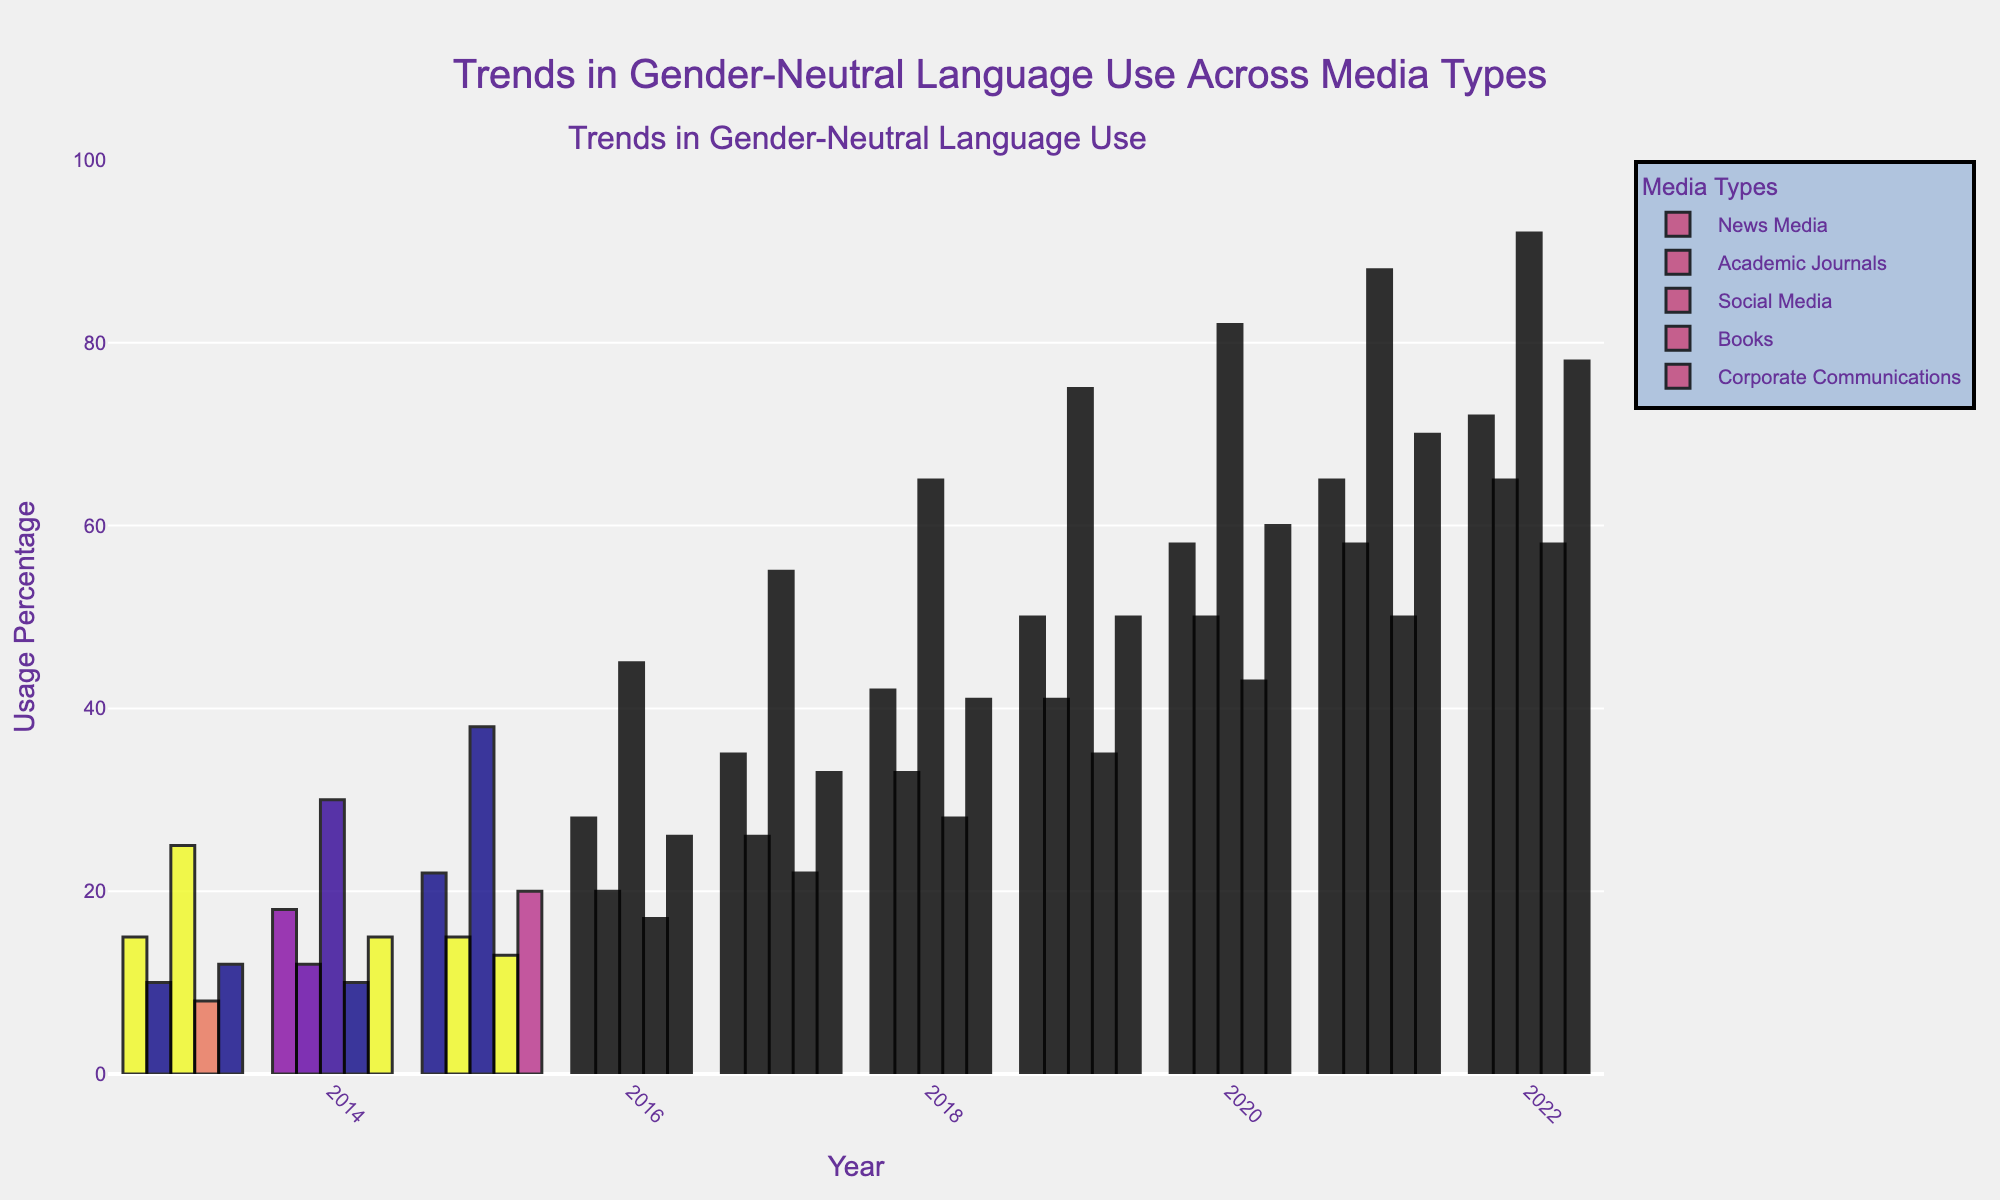What is the trend in the use of gender-neutral language in News Media from 2013 to 2022? First, observe the bars representing News Media from 2013 to 2022. You will notice that the height of the bars increases steadily over the years, indicating a continuous upward trend.
Answer: Continuous upward trend Which media type shows the highest increase in the use of gender-neutral language between 2013 and 2022? Compare the height differences of bars for each media type from 2013 to 2022. Social Media starts at 25 in 2013 and goes up to 92 in 2022, making it the highest increase, which is 67.
Answer: Social Media In 2020, how much higher is the use of gender-neutral language in News Media compared to Books? Identify the bars for News Media and Books in 2020. News Media is at 58, and Books are at 43. Subtract 43 from 58 to find the difference.
Answer: 15 Which media category consistently shows the lowest usage of gender-neutral language over the years? Compare the bars for all categories from 2013 to 2022 and identify the smallest values. Books consistently have the lowest values across all years.
Answer: Books What is the average usage of gender-neutral language in Corporate Communications from 2013 to 2022? Sum the values for Corporate Communications (12 + 15 + 20 + 26 + 33 + 41 + 50 + 60 + 70 + 78) which equals 405. Divide this by the number of years (10) to find the average.
Answer: 40.5 Between which consecutive years did Academic Journals see the highest increase in the use of gender-neutral language? Calculate the year-to-year differences for Academic Journals: 
12-10=2 (2013-2014), 
15-12=3 (2014-2015), 
20-15=5 (2015-2016), 
26-20=6 (2016-2017), 
33-26=7 (2017-2018), 
41-33=8 (2018-2019), 
50-41=9 (2019-2020), 
58-50=8 (2020-2021), 
65-58=7 (2021-2022). 
The highest increase is 9, from 2019 to 2020.
Answer: 2019-2020 How does the use of gender-neutral language in News Media in 2016 compare to that in Corporate Communications in 2022? Look at the values for News Media in 2016 (28) and Corporate Communications in 2022 (78). Corporate Communications in 2022 is significantly higher.
Answer: Corporate Communications in 2022 is higher Which year did the trend in gender-neutral language usage see the greatest increase across all media types combined? Sum up the usage values for each year and compare yearly sums. 
2013: 15+10+25+8+12=70 
2014: 18+12+30+10+15=85 
2015: 22+15+38+13+20=108 
2016: 28+20+45+17+26=136 
2017: 35+26+55+22+33=171 
2018: 42+33+65+28+41=209 
2019: 50+41+75+35+50=251 
2020: 58+50+82+43+60=293 
2021: 65+58+88+50+70=331 
2022: 72+65+92+58+78=365 
The greatest increase is from 2020 (293) to 2021 (331), which is an increase of 38.
Answer: 2020 to 2021 Considering all the years, which media type shows the least variability in the usage of gender-neutral language? Variability can be assessed by examining the differences between the maximum and minimum values for each media type. Calculating for each category: 
- News Media: 72-15=57 
- Academic Journals: 65-10=55 
- Social Media: 92-25=67 
- Books: 58-8=50 
- Corporate Communications: 78-12=66 
Books have the smallest range (50), indicating the least variability.
Answer: Books 